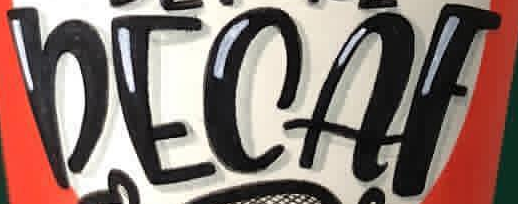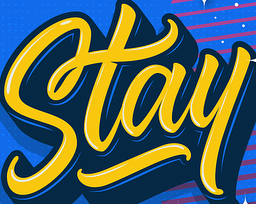What words can you see in these images in sequence, separated by a semicolon? DECAF; Stay 